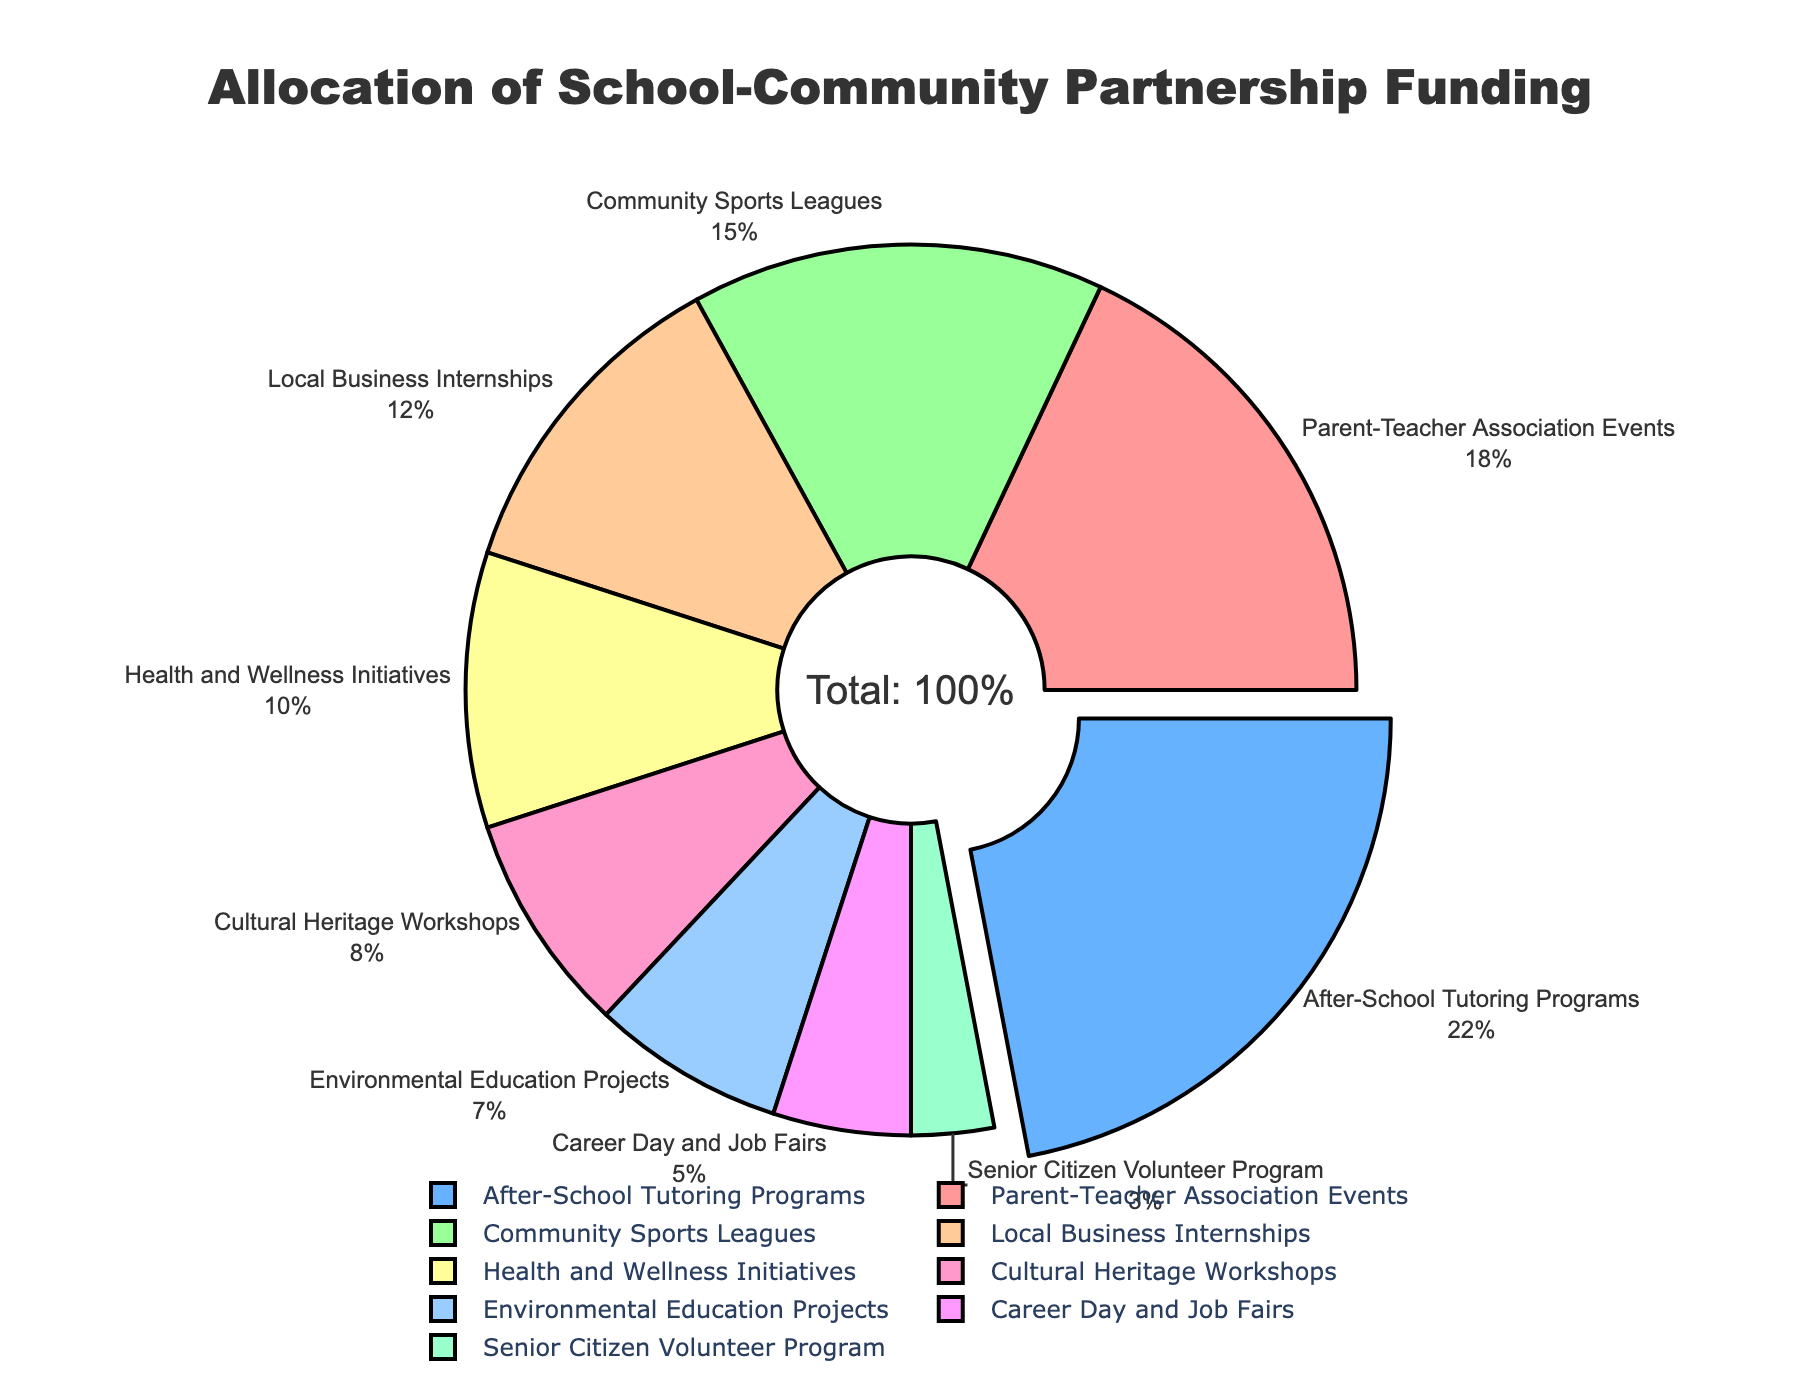Which program receives the most funding? The program with the highest percentage of funding can be identified by looking at the largest section of the pie chart. 'After-School Tutoring Programs' is the largest section, making it the program with the most funding.
Answer: After-School Tutoring Programs How much more funding do After-School Tutoring Programs receive compared to Cultural Heritage Workshops? To find the difference in funding, subtract the percentage for Cultural Heritage Workshops from the percentage for After-School Tutoring Programs: 22% - 8% = 14%.
Answer: 14% What is the total percentage allocated to health and wellness initiatives, environmental education projects, and senior citizen volunteer programs? Sum the percentages for Health and Wellness Initiatives (10%), Environmental Education Projects (7%), and Senior Citizen Volunteer Program (3%): 10% + 7% + 3% = 20%.
Answer: 20% Which two programs receive an equal amount of funding? By examining the pie chart, 'Local Business Internships' and 'Health and Wellness Initiatives' both receive similar funding percentages, but further inspection shows 'Cultural Heritage Workshops' and 'Environmental Education Projects' are both equal at 8% and 7%, respectively
Answer: None What percentage of the funding is allocated to programs other than Parent-Teacher Association Events and After-School Tutoring Programs? Sum the percentages for all programs and subtract the percentages of Parent-Teacher Association Events (18%) and After-School Tutoring Programs (22%): 100% - (18% + 22%) = 60%.
Answer: 60% Which section is represented by the green color? By visually identifying the green section in the pie chart, it corresponds to the program 'Community Sports Leagues'.
Answer: Community Sports Leagues How much less funding do Senior Citizen Volunteer Programs get compared to Local Business Internships? Subtract the percentage of Senior Citizen Volunteer Program (3%) from Local Business Internships (12%): 12% - 3% = 9%.
Answer: 9% What is the average percentage of funding allocated to Career Day and Job Fairs, Senior Citizen Volunteer Program, and Health and Wellness Initiatives? Sum the percentages of these three programs and divide by the number of programs: (5% + 3% + 10%) / 3 = 18% / 3 = 6%.
Answer: 6% Which program has the smallest allocation and how much is it? Identify the smallest section of the pie chart, which represents the Senior Citizen Volunteer Program. It has the smallest allocation at 3%.
Answer: Senior Citizen Volunteer Program and 3% Is the funding allocated to Parent-Teacher Association Events greater than the combined funding of Career Day and Job Fairs, and Senior Citizen Volunteer Program? Sum the percentages for Career Day and Job Fairs (5%) and Senior Citizen Volunteer Program (3%) and compare it to Parent-Teacher Association Events (18%): 5% + 3% = 8%, which is less than 18%.
Answer: Yes 